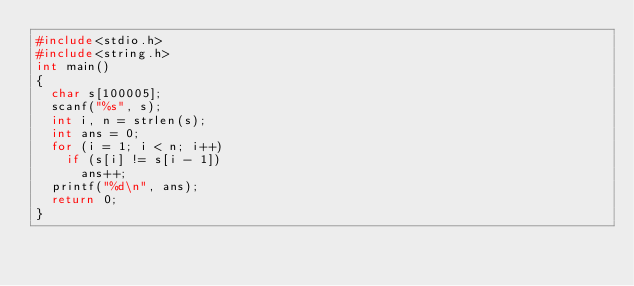Convert code to text. <code><loc_0><loc_0><loc_500><loc_500><_C_>#include<stdio.h>
#include<string.h>
int main()
{
	char s[100005];
	scanf("%s", s);
	int i, n = strlen(s);
	int ans = 0;
	for (i = 1; i < n; i++)
		if (s[i] != s[i - 1])
			ans++;
	printf("%d\n", ans);
	return 0;
}</code> 